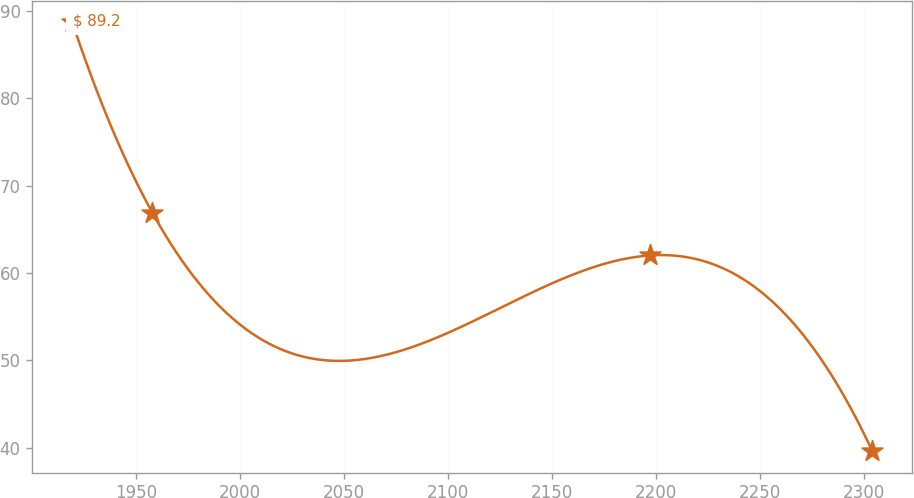<chart> <loc_0><loc_0><loc_500><loc_500><line_chart><ecel><fcel>$ 89.2<nl><fcel>1919.27<fcel>88.69<nl><fcel>1957.74<fcel>66.92<nl><fcel>2196.95<fcel>62.01<nl><fcel>2304.02<fcel>39.61<nl></chart> 